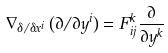Convert formula to latex. <formula><loc_0><loc_0><loc_500><loc_500>\nabla _ { \delta / \delta x ^ { i } } \left ( \partial / \partial y ^ { i } \right ) = F _ { i j } ^ { k } \frac { \partial } { \partial y ^ { k } }</formula> 